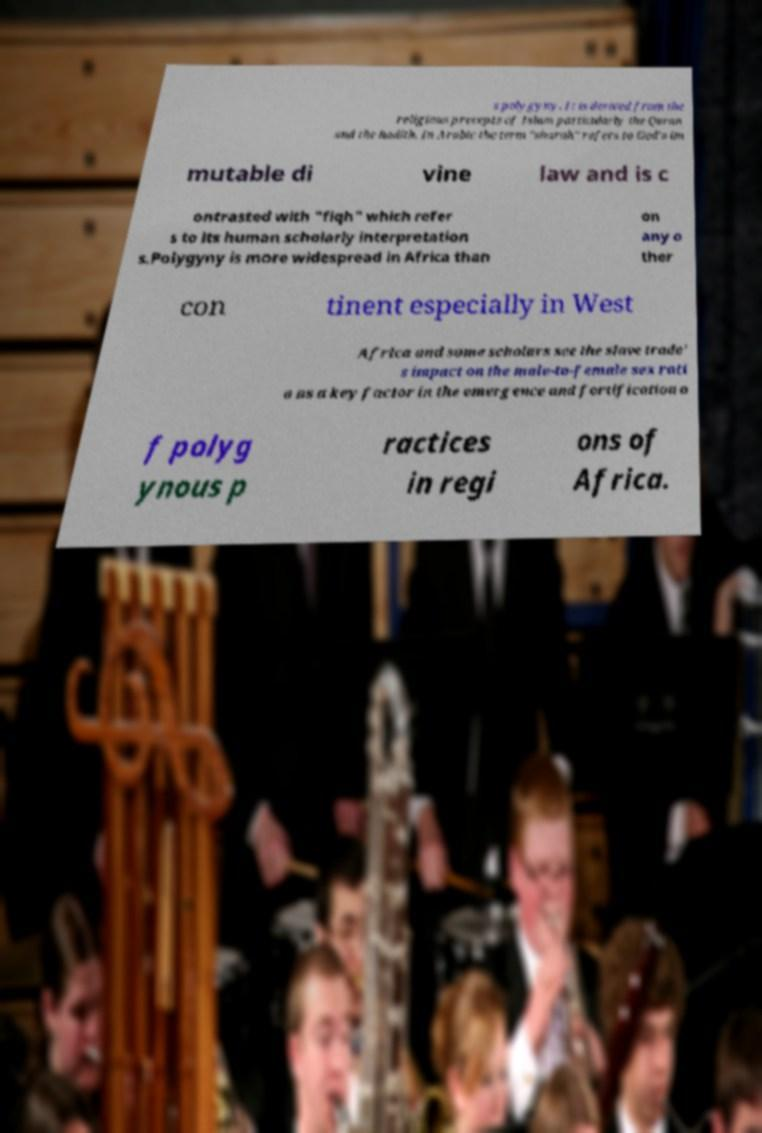There's text embedded in this image that I need extracted. Can you transcribe it verbatim? s polygyny. It is derived from the religious precepts of Islam particularly the Quran and the hadith. In Arabic the term "sharah" refers to God's im mutable di vine law and is c ontrasted with "fiqh" which refer s to its human scholarly interpretation s.Polygyny is more widespread in Africa than on any o ther con tinent especially in West Africa and some scholars see the slave trade' s impact on the male-to-female sex rati o as a key factor in the emergence and fortification o f polyg ynous p ractices in regi ons of Africa. 